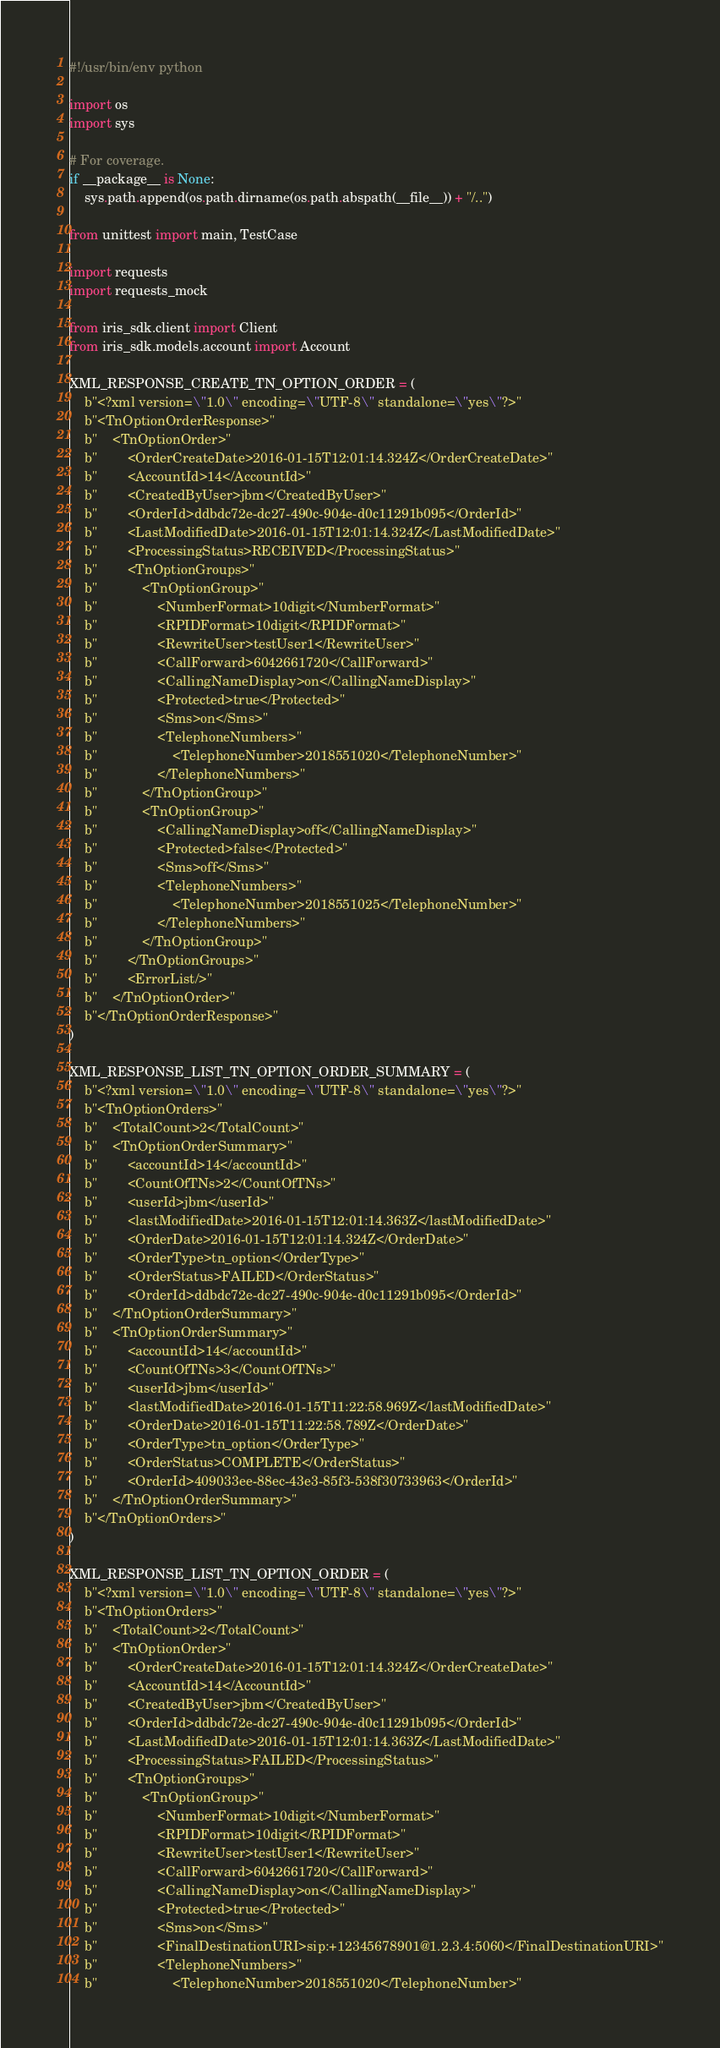Convert code to text. <code><loc_0><loc_0><loc_500><loc_500><_Python_>#!/usr/bin/env python

import os
import sys

# For coverage.
if __package__ is None:
    sys.path.append(os.path.dirname(os.path.abspath(__file__)) + "/..")

from unittest import main, TestCase

import requests
import requests_mock

from iris_sdk.client import Client
from iris_sdk.models.account import Account

XML_RESPONSE_CREATE_TN_OPTION_ORDER = (
    b"<?xml version=\"1.0\" encoding=\"UTF-8\" standalone=\"yes\"?>"
    b"<TnOptionOrderResponse>"
    b"    <TnOptionOrder>"
    b"        <OrderCreateDate>2016-01-15T12:01:14.324Z</OrderCreateDate>"
    b"        <AccountId>14</AccountId>"
    b"        <CreatedByUser>jbm</CreatedByUser>"
    b"        <OrderId>ddbdc72e-dc27-490c-904e-d0c11291b095</OrderId>"
    b"        <LastModifiedDate>2016-01-15T12:01:14.324Z</LastModifiedDate>"
    b"        <ProcessingStatus>RECEIVED</ProcessingStatus>"
    b"        <TnOptionGroups>"
    b"            <TnOptionGroup>"
    b"                <NumberFormat>10digit</NumberFormat>"
    b"                <RPIDFormat>10digit</RPIDFormat>"
    b"                <RewriteUser>testUser1</RewriteUser>"
    b"                <CallForward>6042661720</CallForward>"
    b"                <CallingNameDisplay>on</CallingNameDisplay>"
    b"                <Protected>true</Protected>"
    b"                <Sms>on</Sms>"
    b"                <TelephoneNumbers>"
    b"                    <TelephoneNumber>2018551020</TelephoneNumber>"
    b"                </TelephoneNumbers>"
    b"            </TnOptionGroup>"
    b"            <TnOptionGroup>"
    b"                <CallingNameDisplay>off</CallingNameDisplay>"
    b"                <Protected>false</Protected>"
    b"                <Sms>off</Sms>"
    b"                <TelephoneNumbers>"
    b"                    <TelephoneNumber>2018551025</TelephoneNumber>"
    b"                </TelephoneNumbers>"
    b"            </TnOptionGroup>"
    b"        </TnOptionGroups>"
    b"        <ErrorList/>"
    b"    </TnOptionOrder>"
    b"</TnOptionOrderResponse>"
)

XML_RESPONSE_LIST_TN_OPTION_ORDER_SUMMARY = (
    b"<?xml version=\"1.0\" encoding=\"UTF-8\" standalone=\"yes\"?>"
    b"<TnOptionOrders>"
    b"    <TotalCount>2</TotalCount>"
    b"    <TnOptionOrderSummary>"
    b"        <accountId>14</accountId>"
    b"        <CountOfTNs>2</CountOfTNs>"
    b"        <userId>jbm</userId>"
    b"        <lastModifiedDate>2016-01-15T12:01:14.363Z</lastModifiedDate>"
    b"        <OrderDate>2016-01-15T12:01:14.324Z</OrderDate>"
    b"        <OrderType>tn_option</OrderType>"
    b"        <OrderStatus>FAILED</OrderStatus>"
    b"        <OrderId>ddbdc72e-dc27-490c-904e-d0c11291b095</OrderId>"
    b"    </TnOptionOrderSummary>"
    b"    <TnOptionOrderSummary>"
    b"        <accountId>14</accountId>"
    b"        <CountOfTNs>3</CountOfTNs>"
    b"        <userId>jbm</userId>"
    b"        <lastModifiedDate>2016-01-15T11:22:58.969Z</lastModifiedDate>"
    b"        <OrderDate>2016-01-15T11:22:58.789Z</OrderDate>"
    b"        <OrderType>tn_option</OrderType>"
    b"        <OrderStatus>COMPLETE</OrderStatus>"
    b"        <OrderId>409033ee-88ec-43e3-85f3-538f30733963</OrderId>"
    b"    </TnOptionOrderSummary>"
    b"</TnOptionOrders>"
)

XML_RESPONSE_LIST_TN_OPTION_ORDER = (
    b"<?xml version=\"1.0\" encoding=\"UTF-8\" standalone=\"yes\"?>"
    b"<TnOptionOrders>"
    b"    <TotalCount>2</TotalCount>"
    b"    <TnOptionOrder>"
    b"        <OrderCreateDate>2016-01-15T12:01:14.324Z</OrderCreateDate>"
    b"        <AccountId>14</AccountId>"
    b"        <CreatedByUser>jbm</CreatedByUser>"
    b"        <OrderId>ddbdc72e-dc27-490c-904e-d0c11291b095</OrderId>"
    b"        <LastModifiedDate>2016-01-15T12:01:14.363Z</LastModifiedDate>"
    b"        <ProcessingStatus>FAILED</ProcessingStatus>"
    b"        <TnOptionGroups>"
    b"            <TnOptionGroup>"
    b"                <NumberFormat>10digit</NumberFormat>"
    b"                <RPIDFormat>10digit</RPIDFormat>"
    b"                <RewriteUser>testUser1</RewriteUser>"
    b"                <CallForward>6042661720</CallForward>"
    b"                <CallingNameDisplay>on</CallingNameDisplay>"
    b"                <Protected>true</Protected>"
    b"                <Sms>on</Sms>"
    b"                <FinalDestinationURI>sip:+12345678901@1.2.3.4:5060</FinalDestinationURI>"
    b"                <TelephoneNumbers>"
    b"                    <TelephoneNumber>2018551020</TelephoneNumber>"</code> 